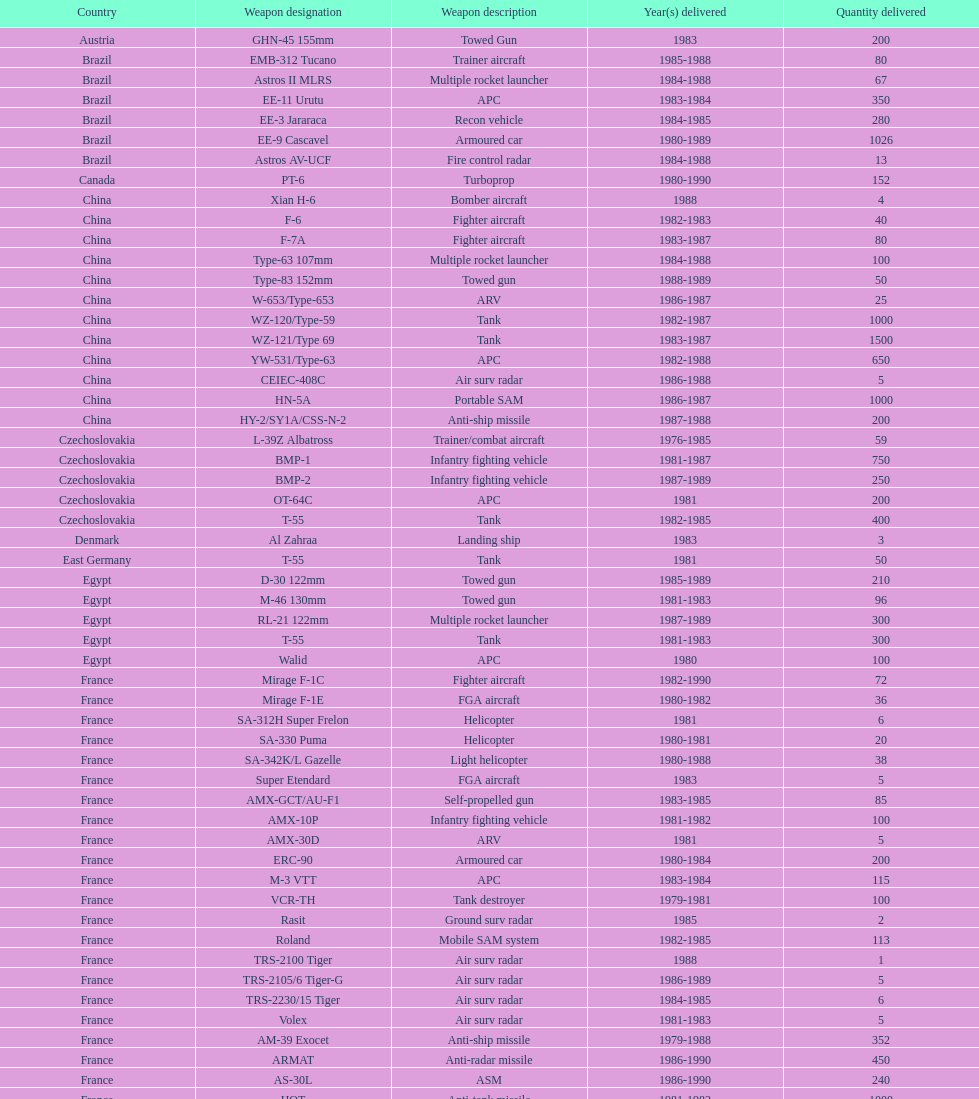In which country were the most towed firearms delivered? Soviet Union. 